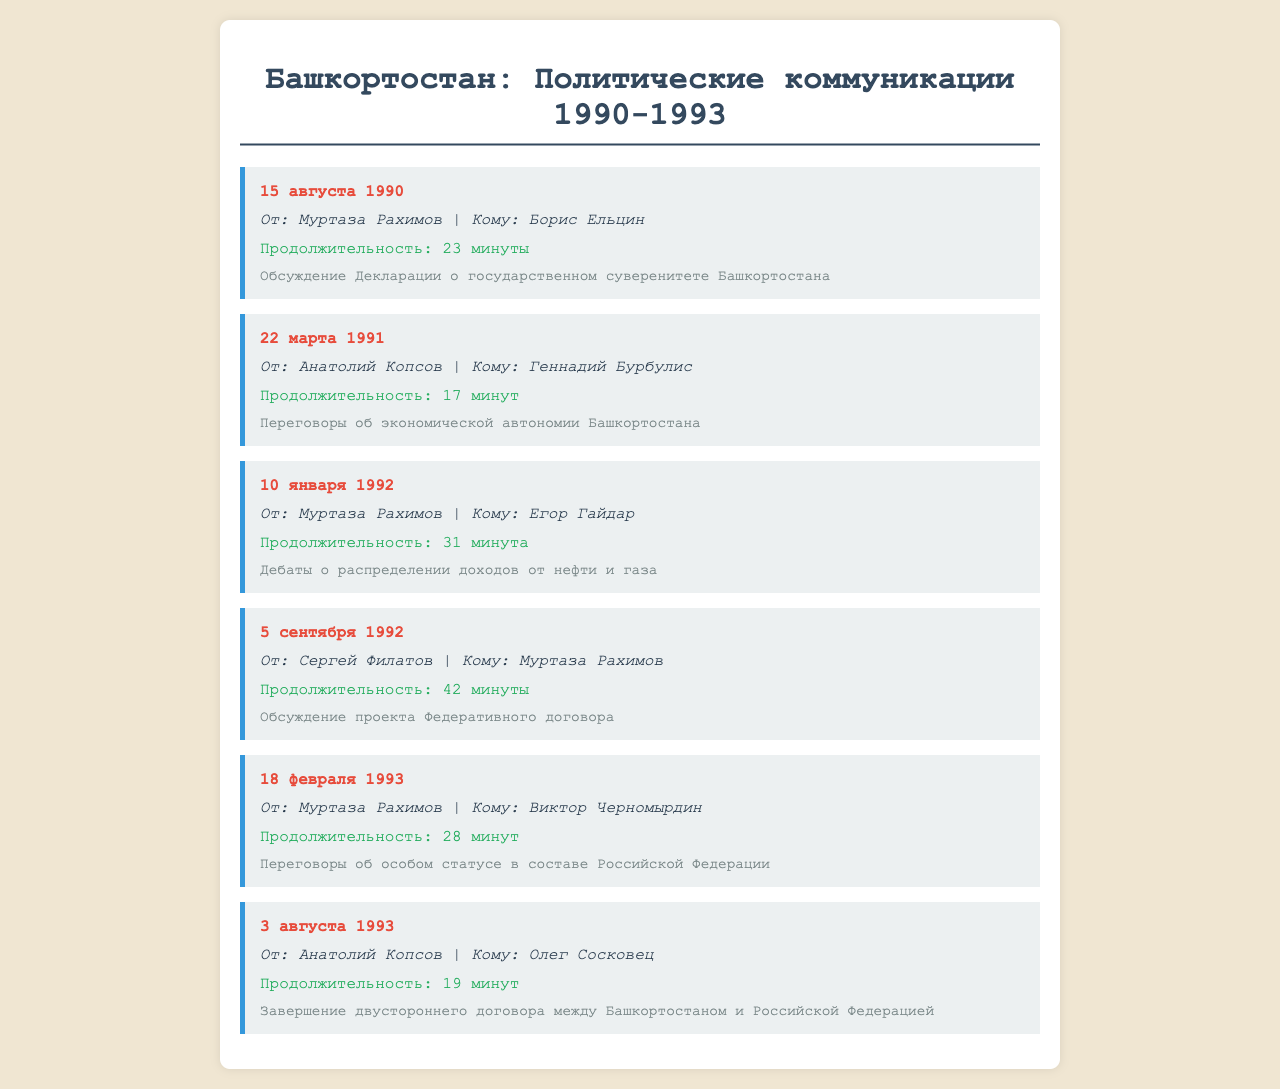What is the date of the first recorded call? The first recorded call is dated 15 августа 1990.
Answer: 15 августа 1990 Who initiated the call on 22 марта 1991? The call was initiated by Анатолий Копсов.
Answer: Анатолий Копсов How long was the call between Муртаза Рахимов and Борис Ельцин? The duration of the call was 23 минуты.
Answer: 23 минуты What was the topic of the conversation on 10 января 1992? The topic was о распределении доходов от нефти и газа.
Answer: распределении доходов от нефти и газа Which official received a call from Сернегий Филатов on 5 сентября 1992? Муртаза Рахимов received the call.
Answer: Муртаза Рахимов What common theme can be seen among the calls between 1990 and 1993? The common theme relates to sovereignty negotiations and autonomous status.
Answer: sovereignty negotiations How many minutes long was the call on 3 августа 1993? The call lasted 19 минут.
Answer: 19 минут What is the relationship between Анатолий Копсов and Олег Сосковец in the context of the document? Анатолий Копсов and Олег Сосковец are linked by the finalization of a bi-lateral agreement.
Answer: finalization of a bi-lateral agreement What action is noted in the call on 18 февраля 1993? The action discussed was "переговоры об особом статусе."
Answer: переговоры об особом статусе 